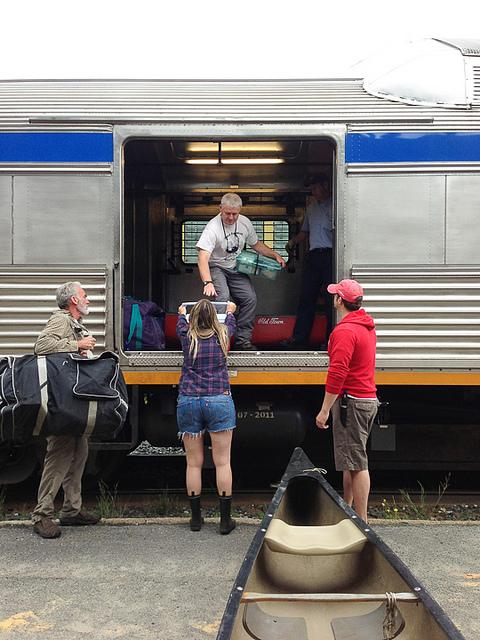What is this type of train car called?

Choices:
A) caboose
B) passenger
C) cargo
D) sleeper cargo 